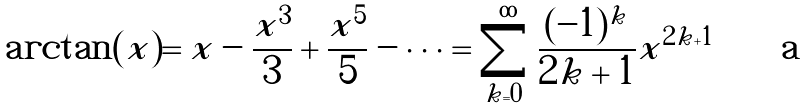<formula> <loc_0><loc_0><loc_500><loc_500>\arctan ( x ) = x - \frac { x ^ { 3 } } { 3 } + \frac { x ^ { 5 } } { 5 } - \dots = \sum _ { k = 0 } ^ { \infty } { \frac { ( - 1 ) ^ { k } } { 2 k + 1 } x ^ { 2 k + 1 } }</formula> 